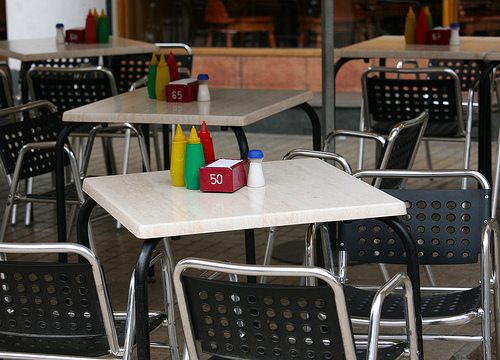<image>
Is the mustard next to the ketchup? Yes. The mustard is positioned adjacent to the ketchup, located nearby in the same general area. Where is the salt in relation to the table? Is it under the table? No. The salt is not positioned under the table. The vertical relationship between these objects is different. 